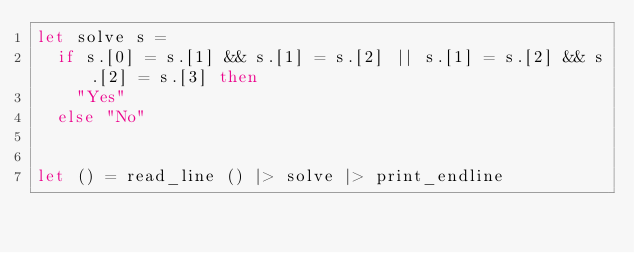Convert code to text. <code><loc_0><loc_0><loc_500><loc_500><_OCaml_>let solve s =
  if s.[0] = s.[1] && s.[1] = s.[2] || s.[1] = s.[2] && s.[2] = s.[3] then
    "Yes"
  else "No"


let () = read_line () |> solve |> print_endline</code> 